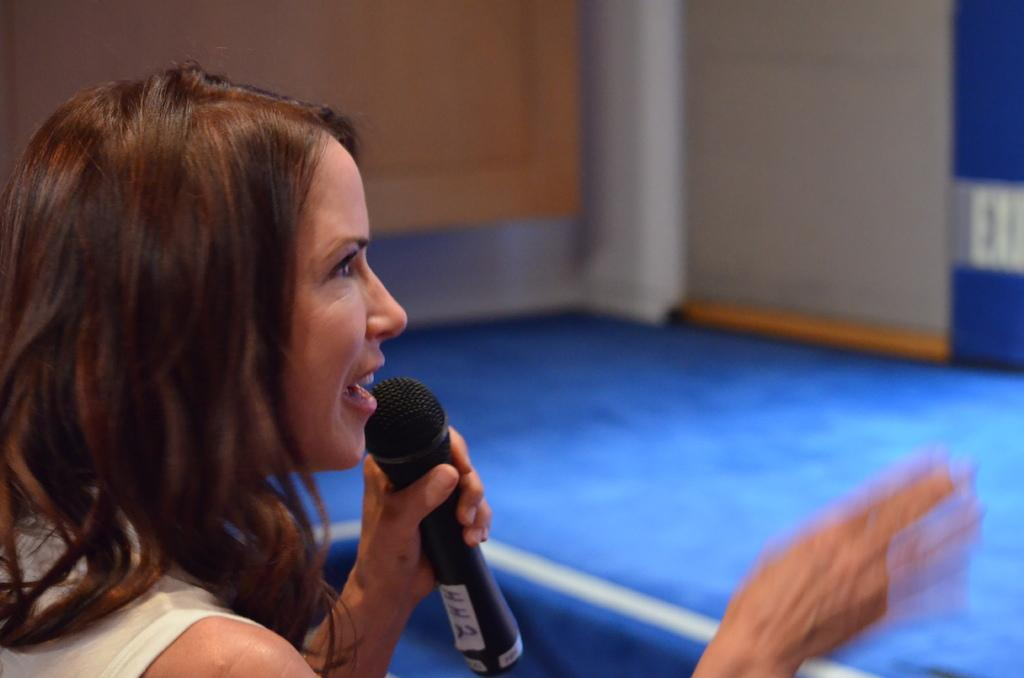Who is the main subject in the image? There is a woman in the image. What is the woman holding in the image? The woman is holding a mic. What is the woman doing in the image? The woman is talking. What can be seen in the background of the image? There is a wall in the background of the image. How would you describe the background in the image? The background appears blurry. How many frogs can be seen on the woman's toes in the image? There are no frogs present on the woman's toes in the image. 